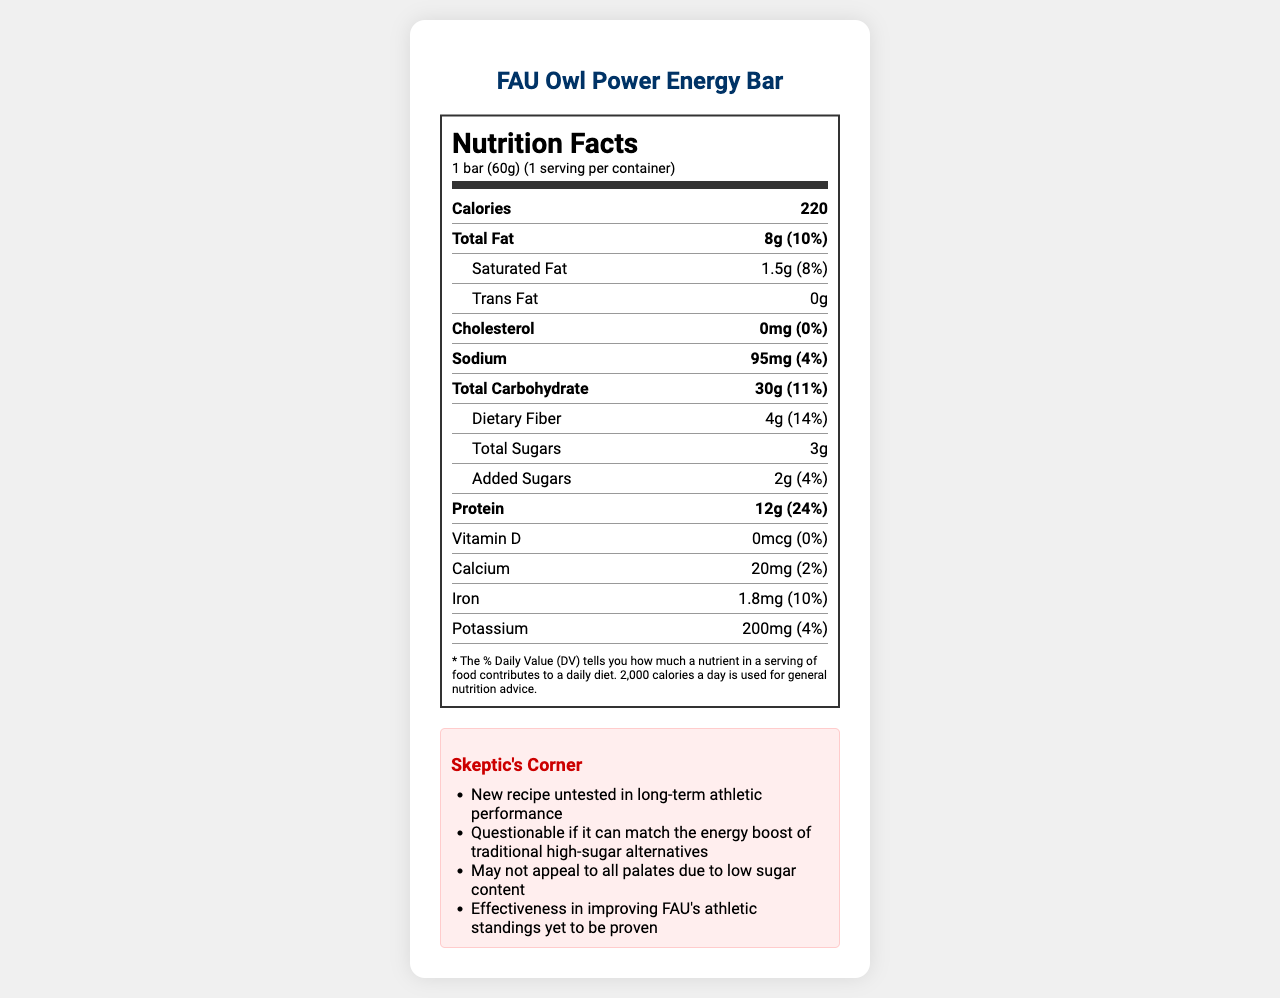how many calories are in one FAU Owl Power Energy Bar? The document specifies that each serving (1 bar) contains 220 calories.
Answer: 220 what is the amount of total sugar in one bar? The document shows that the total sugars per serving are 3g.
Answer: 3g how much protein does the Owl Power bar contain? The nutrition label indicates that there are 12g of protein per bar.
Answer: 12g what is the daily value percentage of dietary fiber in one bar? The label lists the dietary fiber content as 4g, which is 14% of the daily value.
Answer: 14% what are the main allergens in the FAU Owl Power Energy Bar? The allergen information section lists Milk, Peanuts, and Tree Nuts (Almonds) as allergens.
Answer: Milk, Peanuts, Tree Nuts (Almonds) what is the sodium content in one serving of the energy bar? The nutrition label shows that one bar contains 95mg of sodium.
Answer: 95mg how many servings are in each container of Owl Power Energy Bar? The document states that there is one serving per container.
Answer: 1 what is the total fat content of this energy bar? A. 10g B. 8g C. 6g D. 4g The label indicates that the total fat content is 8g per bar.
Answer: B. 8g which claim is made about the Owl Power bar's sugar content? A. No sugar B. Low in sugar C. Sugar-free D. High in sugar One of the listed claims for the product is "Low in sugar".
Answer: B. Low in sugar is there any trans fat in the FAU Owl Power Energy Bar? The nutrition label clearly lists the trans fat content as 0g.
Answer: No does the document provide information about the effectiveness of the new recipe on long-term athletic performance? The skeptic notes mention that the new recipe is untested in long-term athletic performance, but there’s no detailed information provided.
Answer: No, not enough information what are some marketing points highlighted about the Owl Power bar? The marketing points emphasize development by FAU's Sports Nutrition Department, endorsement by Coach Tom Herman, support for peak athletic performance, and low sugar content.
Answer: Developed by FAU's Sports Nutrition Department, Endorsed by Coach Tom Herman, Fuels Owl athletes for peak performance, Only 3g of sugar per bar summarize the key features of the FAU Owl Power Energy Bar based on the document. This summary captures the main nutritional attributes, allergen information, and marketing claims about the energy bar.
Answer: The FAU Owl Power Energy Bar is a low-sugar, high-protein energy bar developed by FAU's Sports Nutrition Department and endorsed by Coach Tom Herman. It contains 220 calories, 8g of fat, 30g of carbs, 12g of protein, and 3g of sugar per bar. The bar also provides dietary fiber (4g), is free of trans fat, but contains peanuts, milk, and almonds as allergens. It aims to fuel athletes for peak performance. 